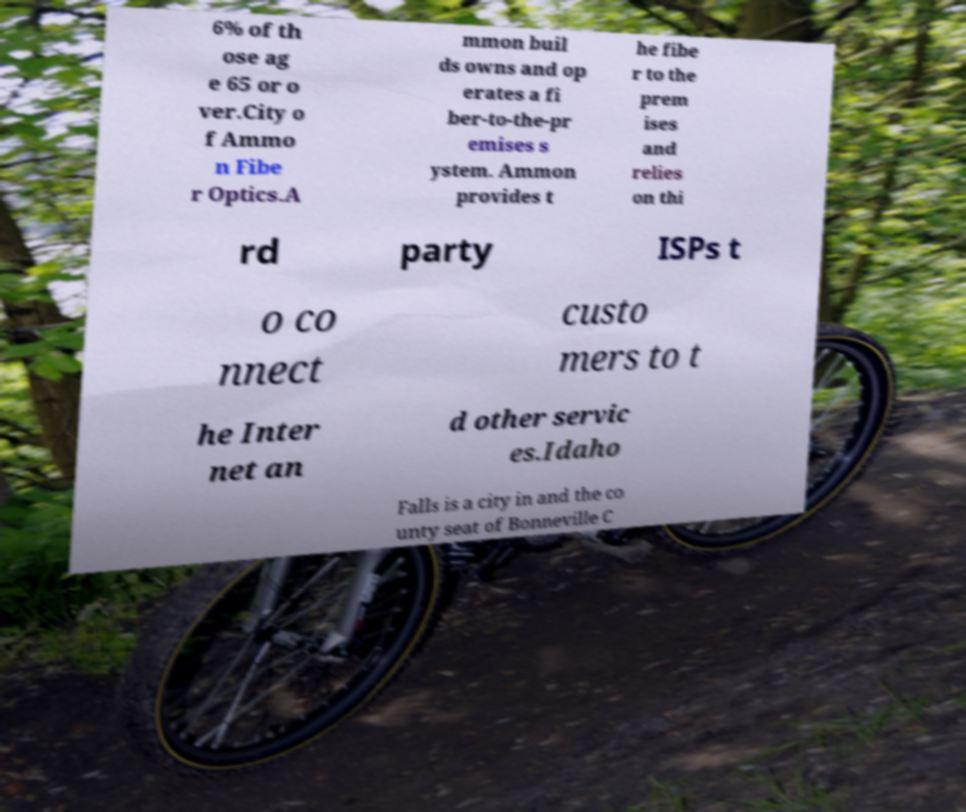There's text embedded in this image that I need extracted. Can you transcribe it verbatim? 6% of th ose ag e 65 or o ver.City o f Ammo n Fibe r Optics.A mmon buil ds owns and op erates a fi ber-to-the-pr emises s ystem. Ammon provides t he fibe r to the prem ises and relies on thi rd party ISPs t o co nnect custo mers to t he Inter net an d other servic es.Idaho Falls is a city in and the co unty seat of Bonneville C 